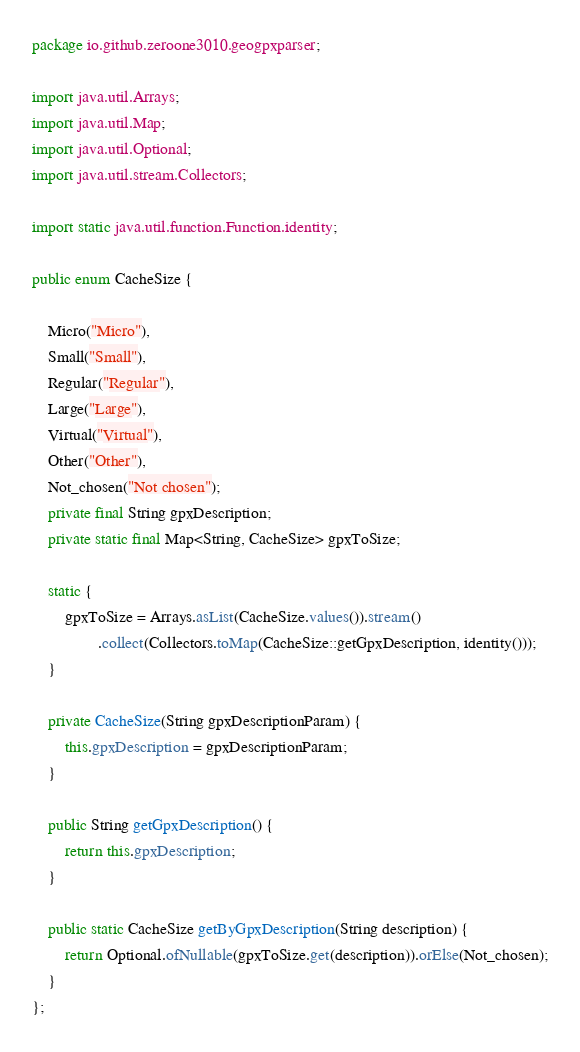<code> <loc_0><loc_0><loc_500><loc_500><_Java_>package io.github.zeroone3010.geogpxparser;

import java.util.Arrays;
import java.util.Map;
import java.util.Optional;
import java.util.stream.Collectors;

import static java.util.function.Function.identity;

public enum CacheSize {

    Micro("Micro"),
    Small("Small"),
    Regular("Regular"),
    Large("Large"),
    Virtual("Virtual"),
    Other("Other"),
    Not_chosen("Not chosen");
    private final String gpxDescription;
    private static final Map<String, CacheSize> gpxToSize;

    static {
        gpxToSize = Arrays.asList(CacheSize.values()).stream()
                .collect(Collectors.toMap(CacheSize::getGpxDescription, identity()));
    }

    private CacheSize(String gpxDescriptionParam) {
        this.gpxDescription = gpxDescriptionParam;
    }

    public String getGpxDescription() {
        return this.gpxDescription;
    }

    public static CacheSize getByGpxDescription(String description) {
        return Optional.ofNullable(gpxToSize.get(description)).orElse(Not_chosen);
    }
};
</code> 